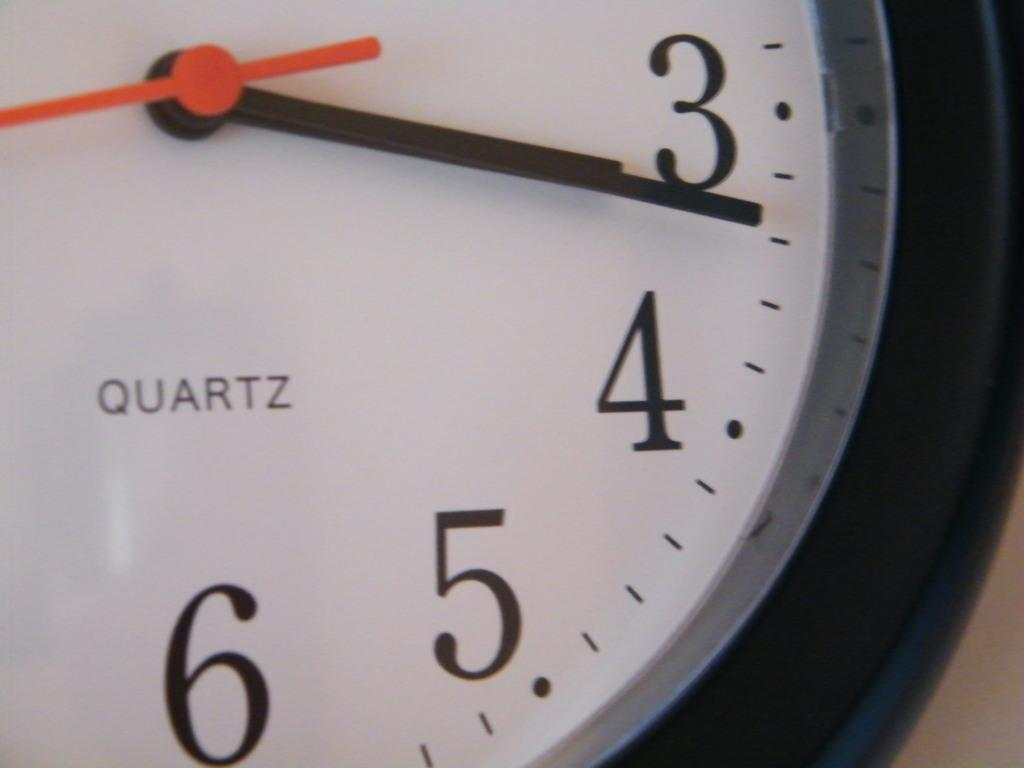<image>
Describe the image concisely. White and black clock which has the word "QUARTZ" on it. 